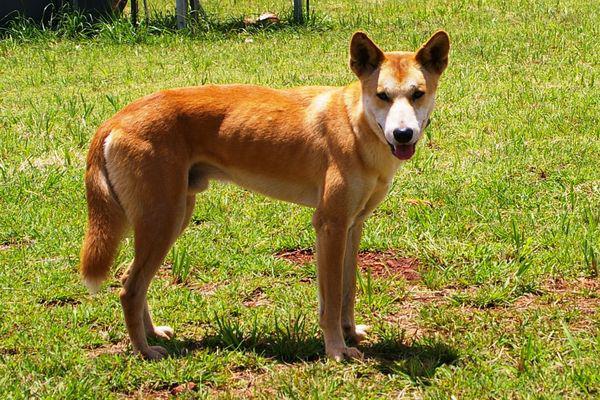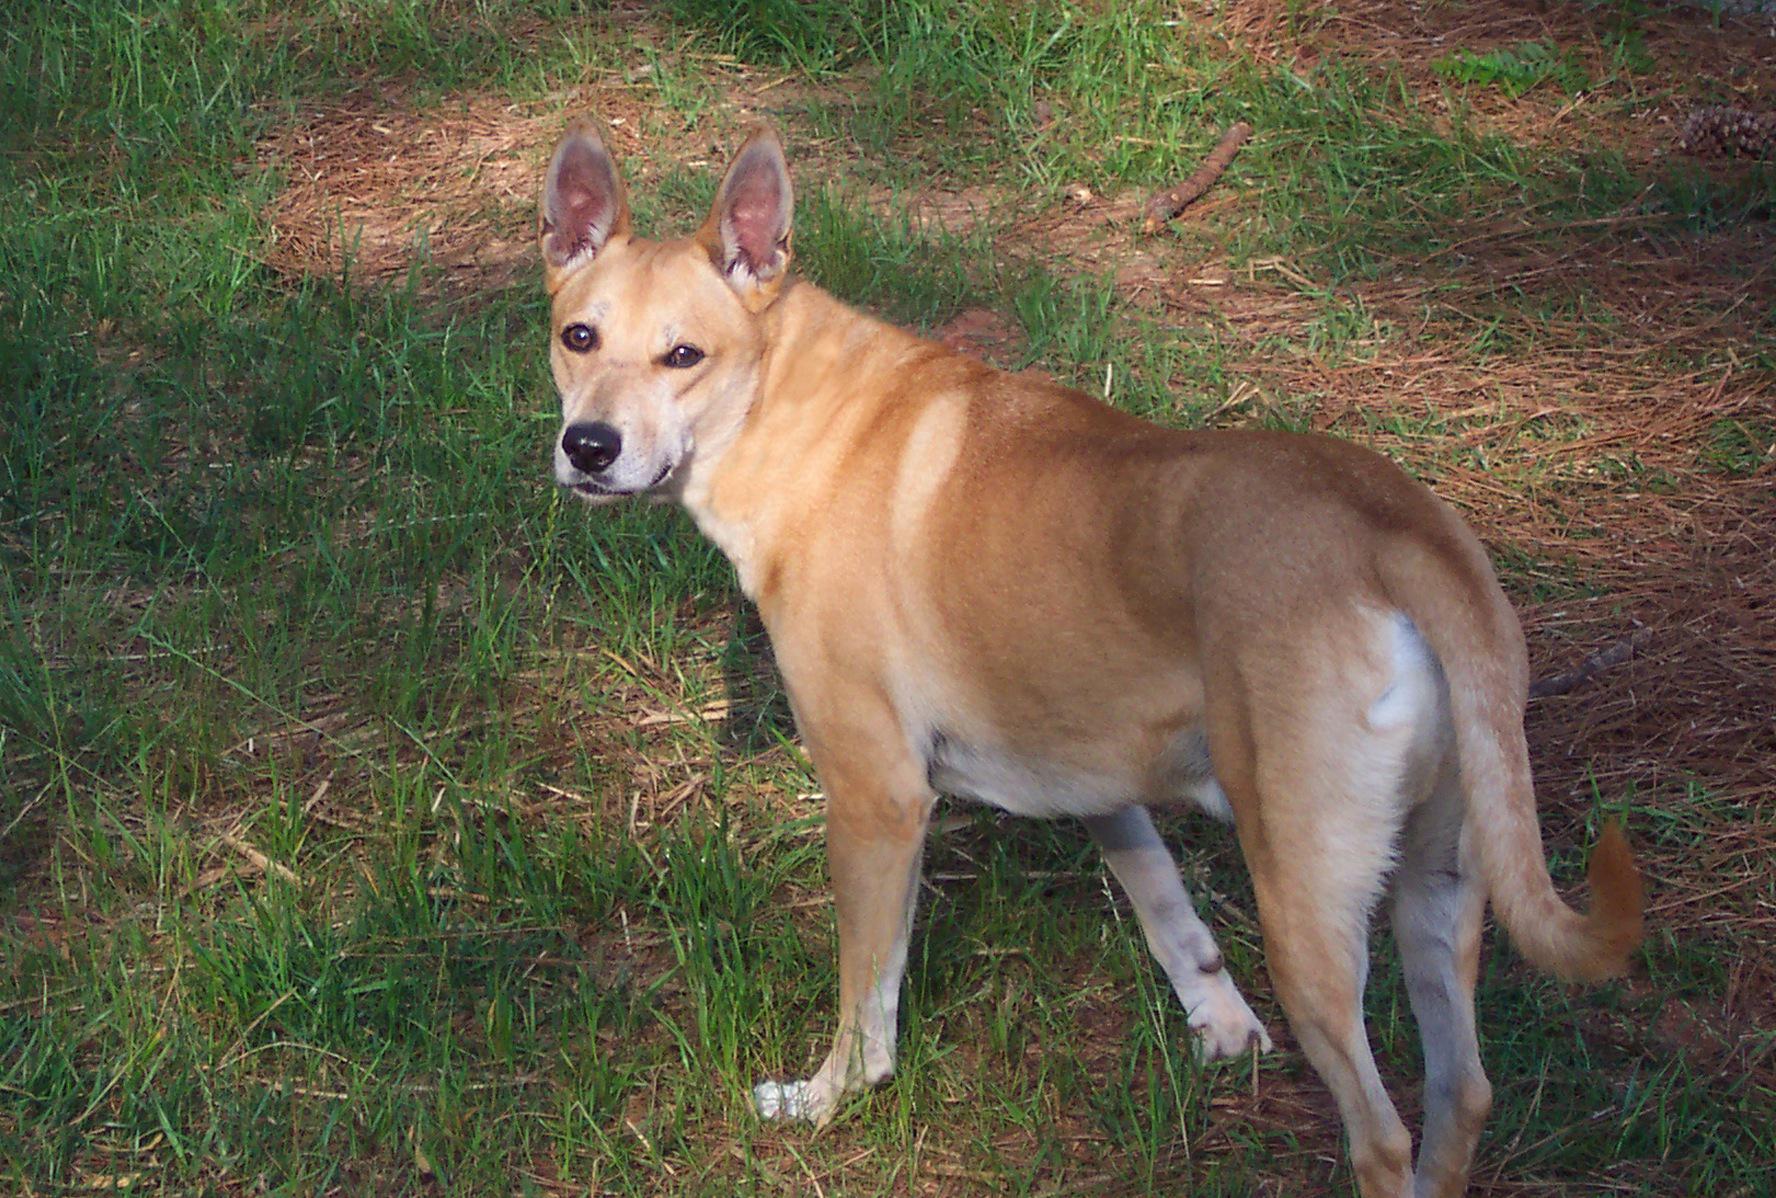The first image is the image on the left, the second image is the image on the right. Given the left and right images, does the statement "An image shows at least one dog looking completely to the side." hold true? Answer yes or no. No. 